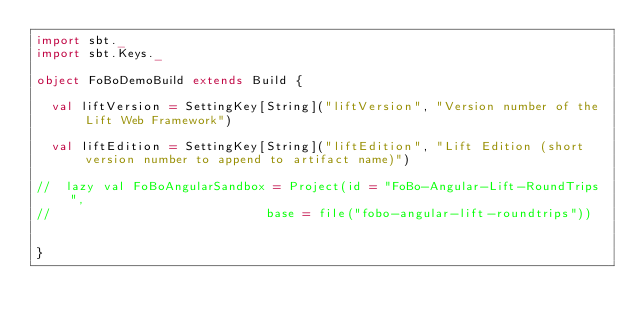Convert code to text. <code><loc_0><loc_0><loc_500><loc_500><_Scala_>import sbt._
import sbt.Keys._

object FoBoDemoBuild extends Build {

  val liftVersion = SettingKey[String]("liftVersion", "Version number of the Lift Web Framework")
  
  val liftEdition = SettingKey[String]("liftEdition", "Lift Edition (short version number to append to artifact name)") 
  
//  lazy val FoBoAngularSandbox = Project(id = "FoBo-Angular-Lift-RoundTrips",
//                             base = file("fobo-angular-lift-roundtrips")) 
                             
 
}
</code> 